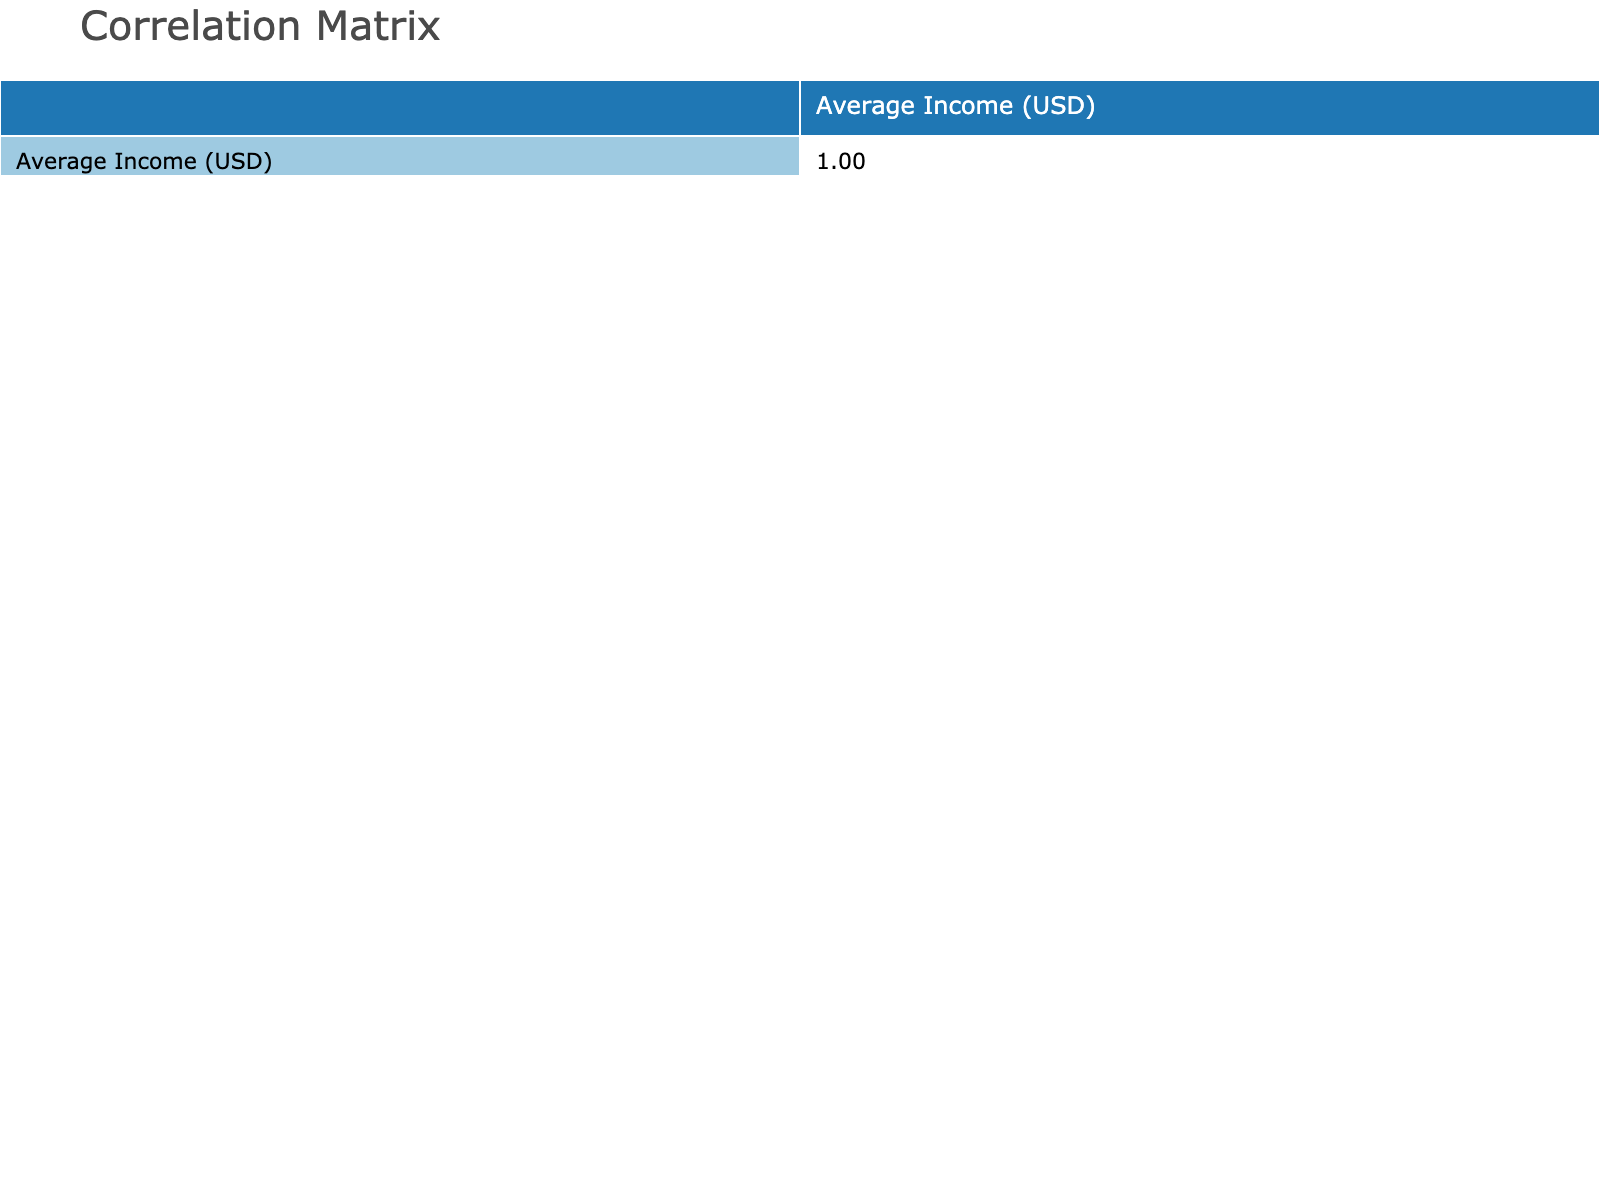What is the average income of a Data Scientist? The table shows the average income for a Data Scientist is listed directly beside the profession; it states an average income of 110000 USD.
Answer: 110000 USD Which profession has the highest income, and what is that income? By examining the average income values associated with each profession, it is clear that the Physician role has the highest income of 220000 USD.
Answer: Physician, 220000 USD Is there any profession with an average income of less than 60000 USD? The table lists average incomes for all professions. The lowest average income presented is 55000 USD for a Graphic Designer, confirming that at least one profession does have an average income under 60000 USD.
Answer: Yes Which education level is most common among professions listed, and what professions belong to it? By reviewing the table, multiple professions share the Bachelor's Degree as the education level. These professions include Software Engineer, Civil Engineer, High School Teacher, Graphic Designer, Construction Manager, and Accountant.
Answer: Bachelor's Degree: Software Engineer, Civil Engineer, High School Teacher, Graphic Designer, Construction Manager, Accountant What is the difference in average income between Nurses and Electricians? From the table, the average income for Nurses is 70000 USD and for Electricians is also 60000 USD. The difference in income is calculated as 70000 - 60000 = 10000 USD.
Answer: 10000 USD Is the average income of a Pharmacist greater than that of a Financial Analyst? By comparing the values in the table, the average income for Pharmacists is 125000 USD versus 80000 USD for Financial Analysts. Therefore, the income for Pharmacists is indeed greater.
Answer: Yes What is the overall average income of all the education levels presented in the table? To find the overall average, sum all the average incomes (90000 + 110000 + 70000 + 95000 + 60000 + 220000 + 55000 + 80000 + 125000 + 85000 + 60000 + 95000 + 100000 + 70000 + 120000 + 75000) which equals  1000000 USD and divide by the number of professions (16), yielding approximately 62500 USD.
Answer: 62500 USD How many professions require a Master's Degree, and what are they? Counting the rows in the table, the professions that require a Master's Degree include Data Scientist, Financial Analyst, Marketing Manager, and Hospital Administrator, totaling four professions.
Answer: 4 professions: Data Scientist, Financial Analyst, Marketing Manager, Hospital Administrator What is the average income of all professions that require a Doctorate? The average income for Doctorate professions (Physician and Pharmacist) can be calculated by summing their incomes (220000 + 125000 = 345000 USD) and dividing by the number of Doctorate professions (2), resulting in an average of 172500 USD.
Answer: 172500 USD 